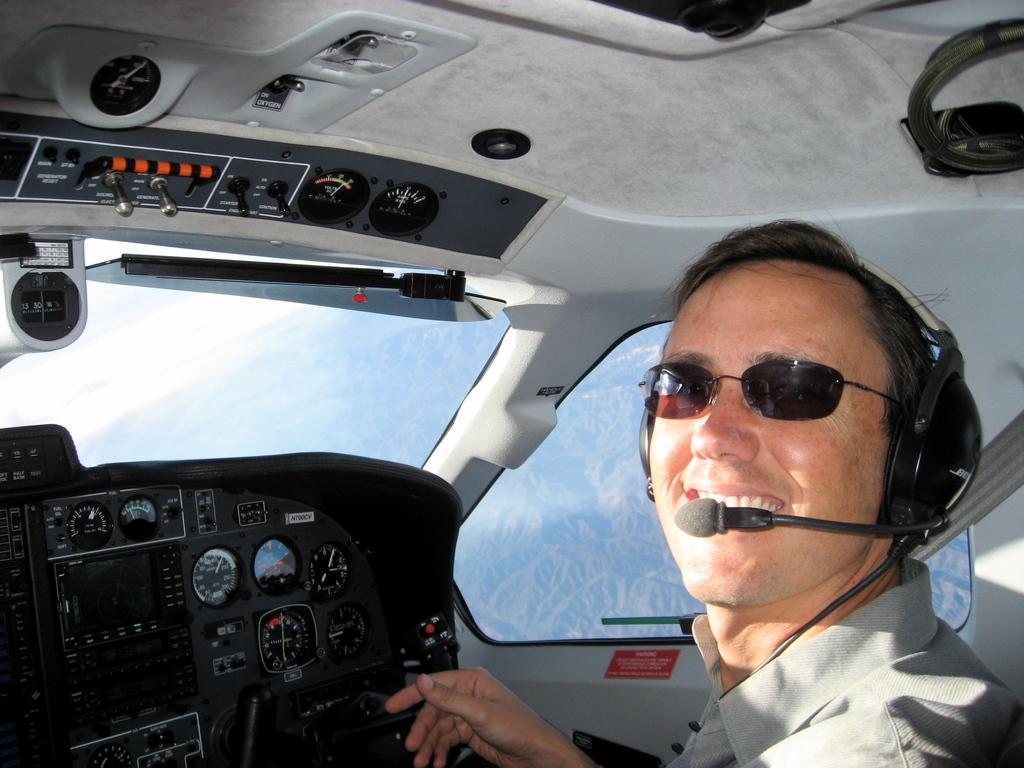Who or what is the main subject in the image? There is a person in the image. Can you describe the person's appearance? The person is wearing clothes and spectacles. What additional items can be seen in the image? There are headsets visible in the image. What is the background of the image? There is an internal structure of a flying jet and a mountain in the image. What type of soup is being served in the image? There is no soup present in the image. What color is the person's shirt in the image? The provided facts do not mention the color of the person's shirt, only that they are wearing clothes. --- Facts: 1. There is a person holding a book in the image. 2. The book has a blue cover. 3. The person is sitting on a chair. 4. There is a table in the image. 5. The table has a lamp on it. Absurd Topics: fish, bicycle, ocean Conversation: What is the person in the image holding? The person is holding a book in the image. Can you describe the book's appearance? The book has a blue cover. Where is the person sitting in the image? The person is sitting on a chair. What other objects can be seen in the image? There is a table in the image, and a lamp is on the table. Reasoning: Let's think step by step in order to produce the conversation. We start by identifying the main subject in the image, which is the person holding a book. Then, we expand the conversation to include details about the book's appearance, such as its blue cover. Next, we mention the person's location, which is sitting on a chair. Finally, we describe the other objects visible in the image, which are the table and the lamp on it. Absurd Question/Answer: How many fish can be seen swimming in the ocean in the image? There is no ocean or fish present in the image. Is the person riding a bicycle in the image? There is no bicycle present in the image. 